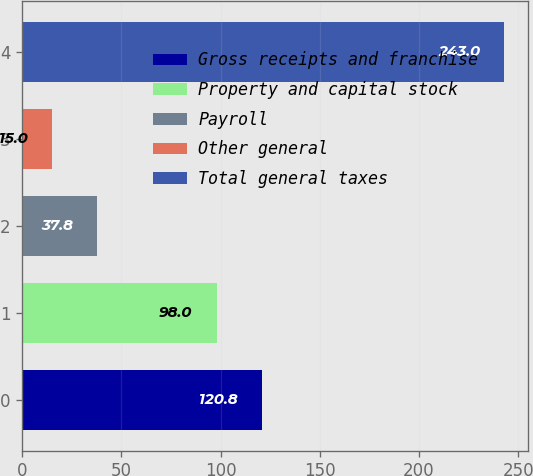Convert chart to OTSL. <chart><loc_0><loc_0><loc_500><loc_500><bar_chart><fcel>Gross receipts and franchise<fcel>Property and capital stock<fcel>Payroll<fcel>Other general<fcel>Total general taxes<nl><fcel>120.8<fcel>98<fcel>37.8<fcel>15<fcel>243<nl></chart> 